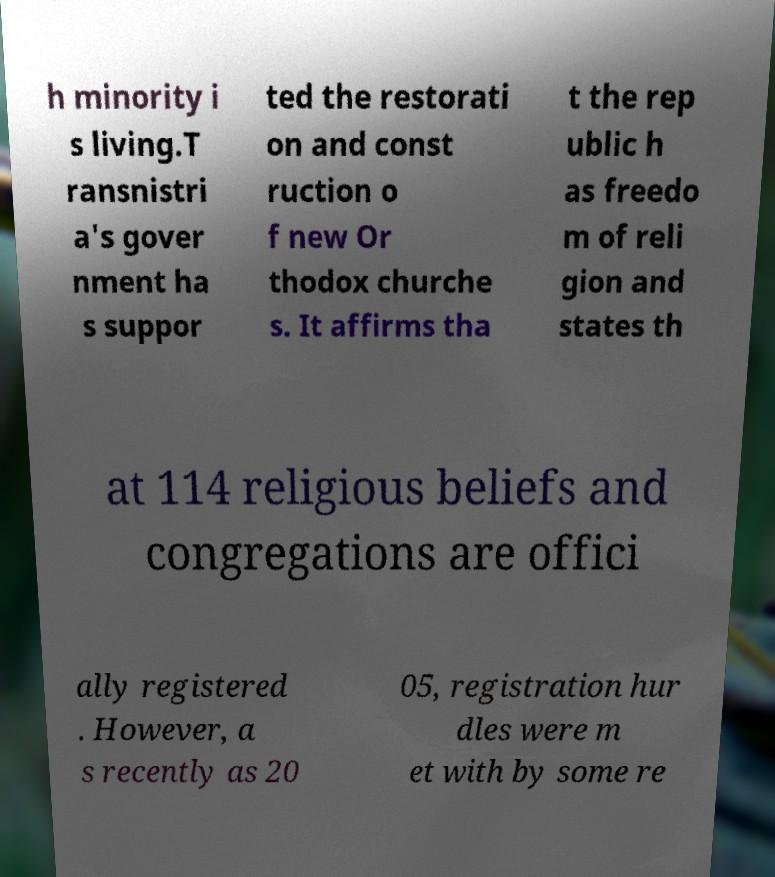Please read and relay the text visible in this image. What does it say? h minority i s living.T ransnistri a's gover nment ha s suppor ted the restorati on and const ruction o f new Or thodox churche s. It affirms tha t the rep ublic h as freedo m of reli gion and states th at 114 religious beliefs and congregations are offici ally registered . However, a s recently as 20 05, registration hur dles were m et with by some re 